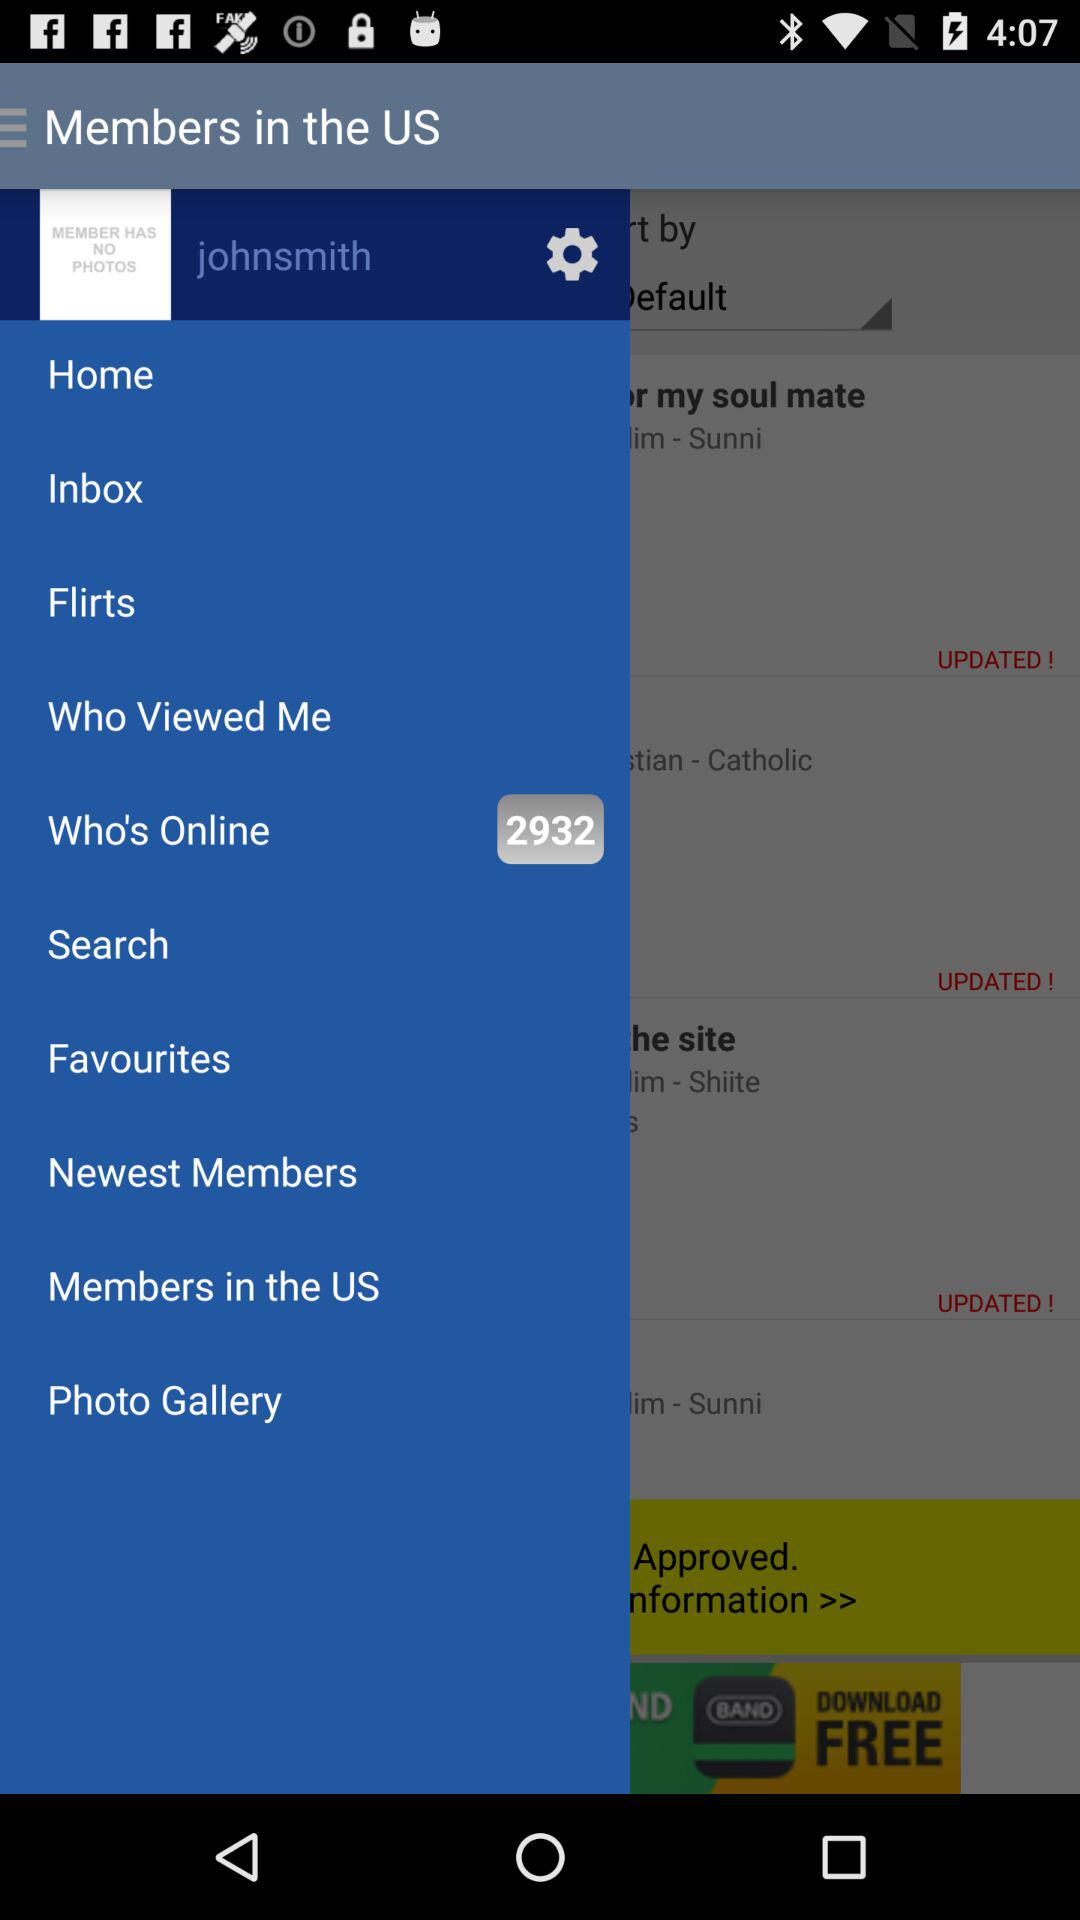How many users are found online? There are 2932 users found online. 